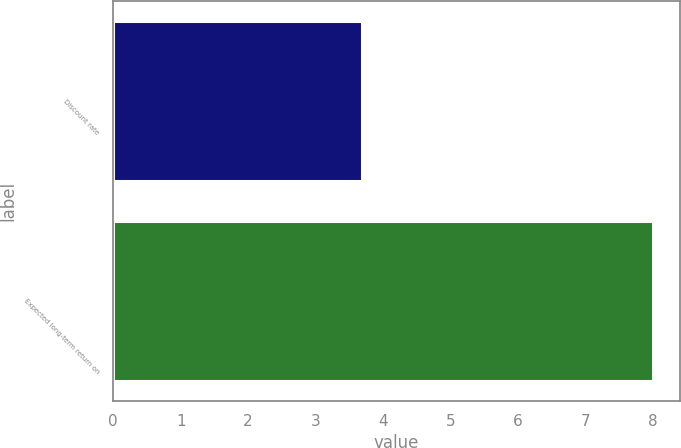<chart> <loc_0><loc_0><loc_500><loc_500><bar_chart><fcel>Discount rate<fcel>Expected long-term return on<nl><fcel>3.68<fcel>8<nl></chart> 